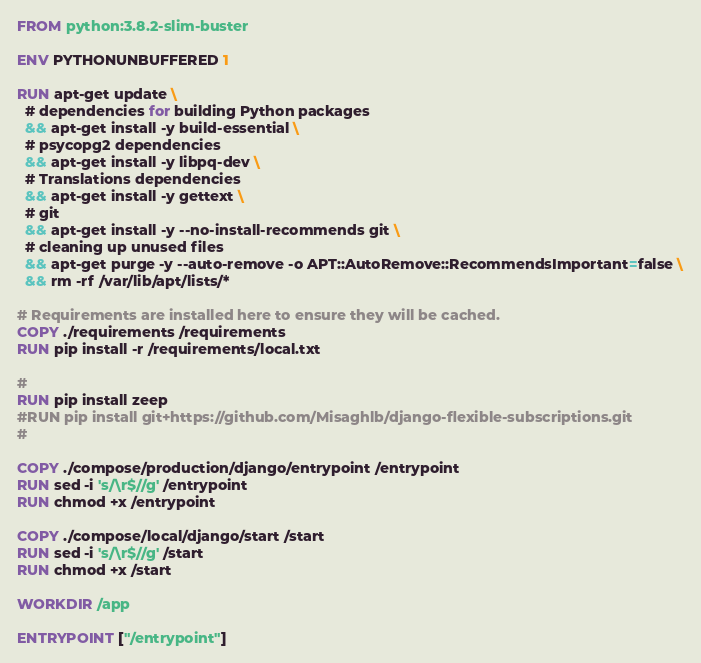<code> <loc_0><loc_0><loc_500><loc_500><_Dockerfile_>FROM python:3.8.2-slim-buster

ENV PYTHONUNBUFFERED 1

RUN apt-get update \
  # dependencies for building Python packages
  && apt-get install -y build-essential \
  # psycopg2 dependencies
  && apt-get install -y libpq-dev \
  # Translations dependencies
  && apt-get install -y gettext \
  # git
  && apt-get install -y --no-install-recommends git \
  # cleaning up unused files
  && apt-get purge -y --auto-remove -o APT::AutoRemove::RecommendsImportant=false \
  && rm -rf /var/lib/apt/lists/*

# Requirements are installed here to ensure they will be cached.
COPY ./requirements /requirements
RUN pip install -r /requirements/local.txt

#
RUN pip install zeep
#RUN pip install git+https://github.com/Misaghlb/django-flexible-subscriptions.git
#

COPY ./compose/production/django/entrypoint /entrypoint
RUN sed -i 's/\r$//g' /entrypoint
RUN chmod +x /entrypoint

COPY ./compose/local/django/start /start
RUN sed -i 's/\r$//g' /start
RUN chmod +x /start

WORKDIR /app

ENTRYPOINT ["/entrypoint"]
</code> 